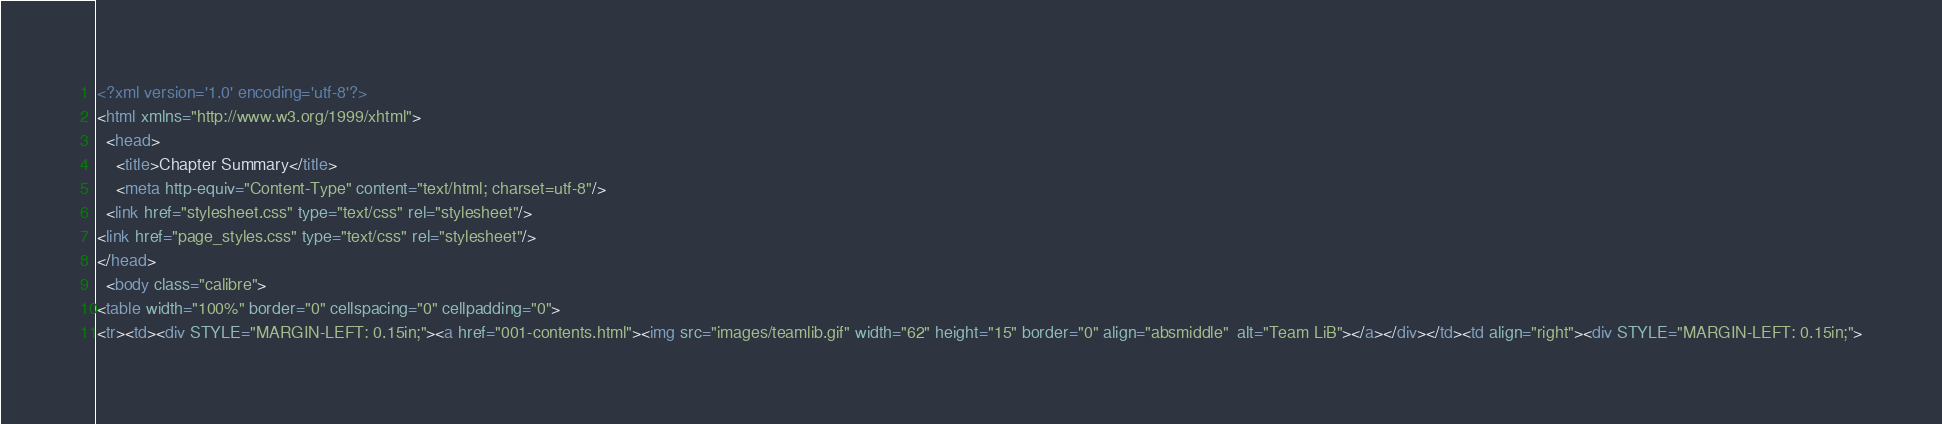Convert code to text. <code><loc_0><loc_0><loc_500><loc_500><_HTML_><?xml version='1.0' encoding='utf-8'?>
<html xmlns="http://www.w3.org/1999/xhtml">
  <head>
    <title>Chapter Summary</title>
    <meta http-equiv="Content-Type" content="text/html; charset=utf-8"/>
  <link href="stylesheet.css" type="text/css" rel="stylesheet"/>
<link href="page_styles.css" type="text/css" rel="stylesheet"/>
</head>
  <body class="calibre">
<table width="100%" border="0" cellspacing="0" cellpadding="0">
<tr><td><div STYLE="MARGIN-LEFT: 0.15in;"><a href="001-contents.html"><img src="images/teamlib.gif" width="62" height="15" border="0" align="absmiddle"  alt="Team LiB"></a></div></td><td align="right"><div STYLE="MARGIN-LEFT: 0.15in;"></code> 